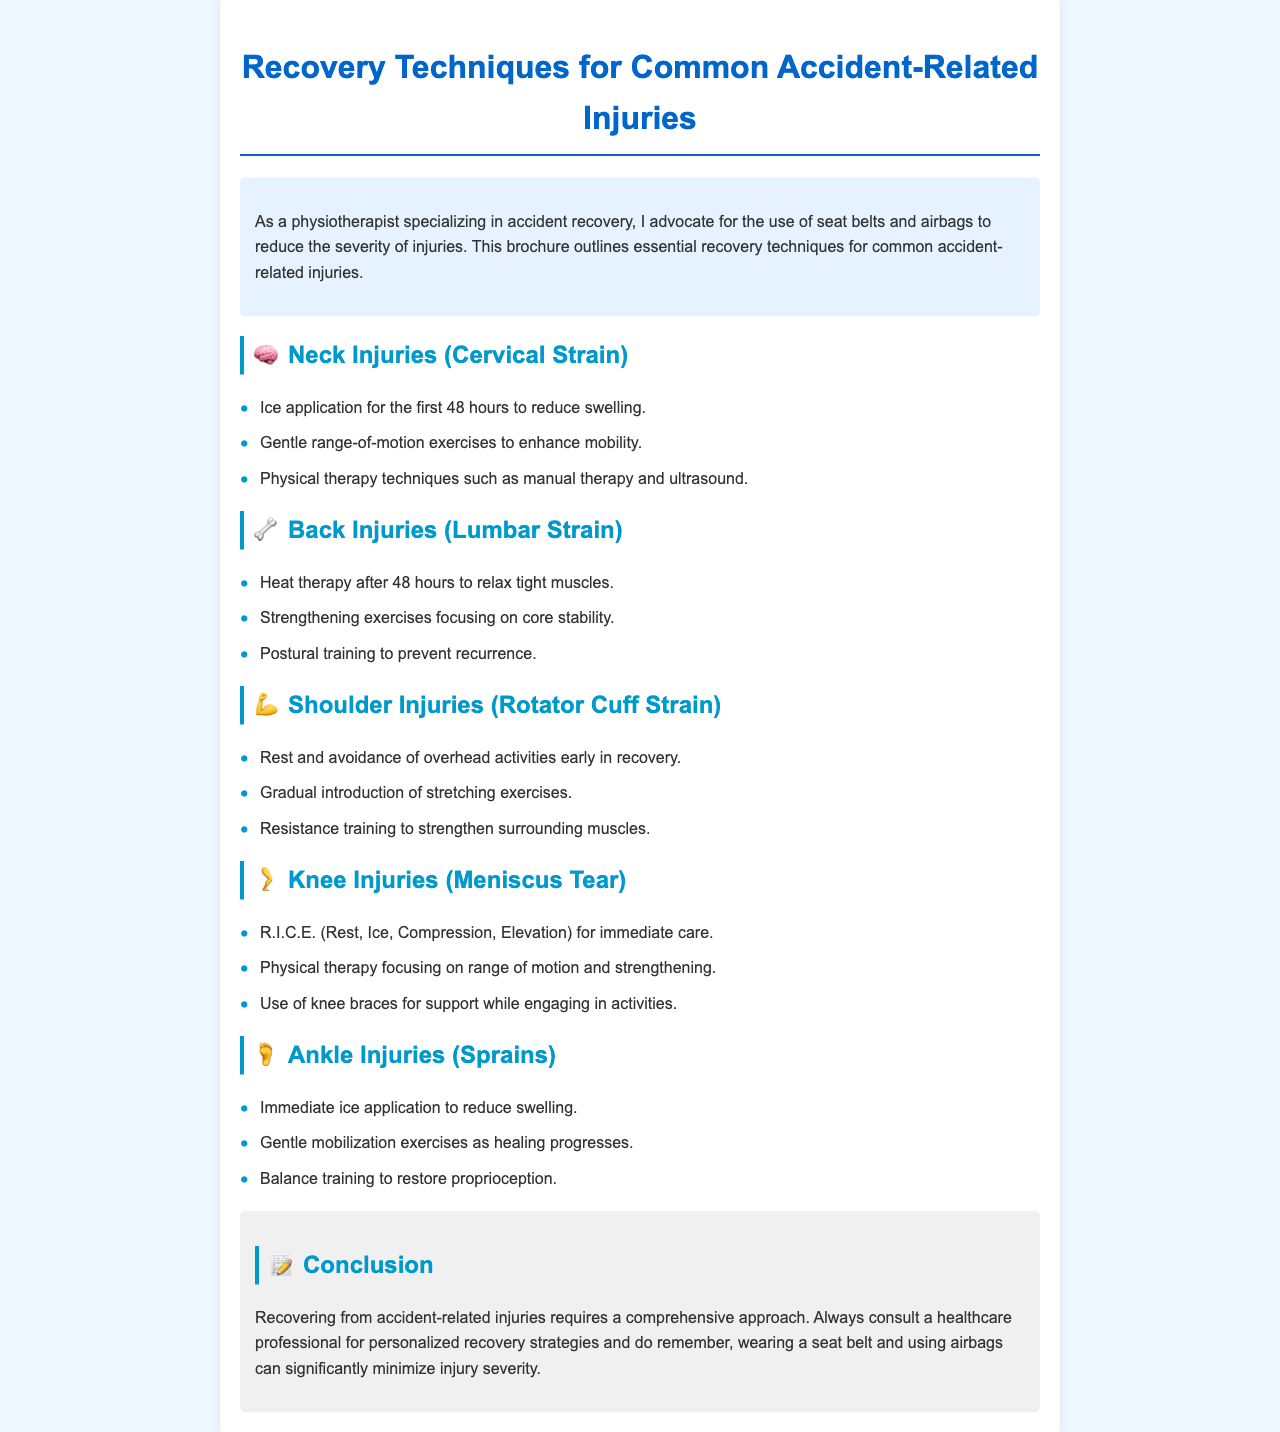What are the recovery techniques for neck injuries? The section on neck injuries lists techniques such as ice application, gentle range-of-motion exercises, and physical therapy techniques.
Answer: Ice application, gentle range-of-motion exercises, physical therapy techniques What is the acronym used for caring for knee injuries? The document specifies immediate care for knee injuries using the acronym R.I.C.E.
Answer: R.I.C.E What type of therapy is recommended after 48 hours for back injuries? The document states that heat therapy is recommended after the initial 48 hours for lumbar strain injuries.
Answer: Heat therapy What is a key focus in physical therapy for knee injuries? The document mentions that physical therapy for knee injuries focuses on range of motion and strengthening.
Answer: Range of motion and strengthening What should be avoided early in recovery for shoulder injuries? The brochure advises avoiding overhead activities early in the recovery process for shoulder injuries.
Answer: Overhead activities What color is used for the heading of the conclusion section? The heading for the conclusion section uses the same color as other section titles but specifically is showcased in blue.
Answer: Blue How long should ice be applied for neck injuries? The document specifies that ice should be applied for the first 48 hours for neck injuries.
Answer: First 48 hours What are the two goals in recovery for ankle injuries? The brochure outlines gentle mobilization exercises and balance training as key goals in recovery for ankle injuries.
Answer: Gentle mobilization exercises and balance training What is emphasized alongside recovery techniques in the conclusion? The conclusion emphasizes the importance of wearing a seat belt and using airbags in reducing injury severity.
Answer: Wearing a seat belt and using airbags 